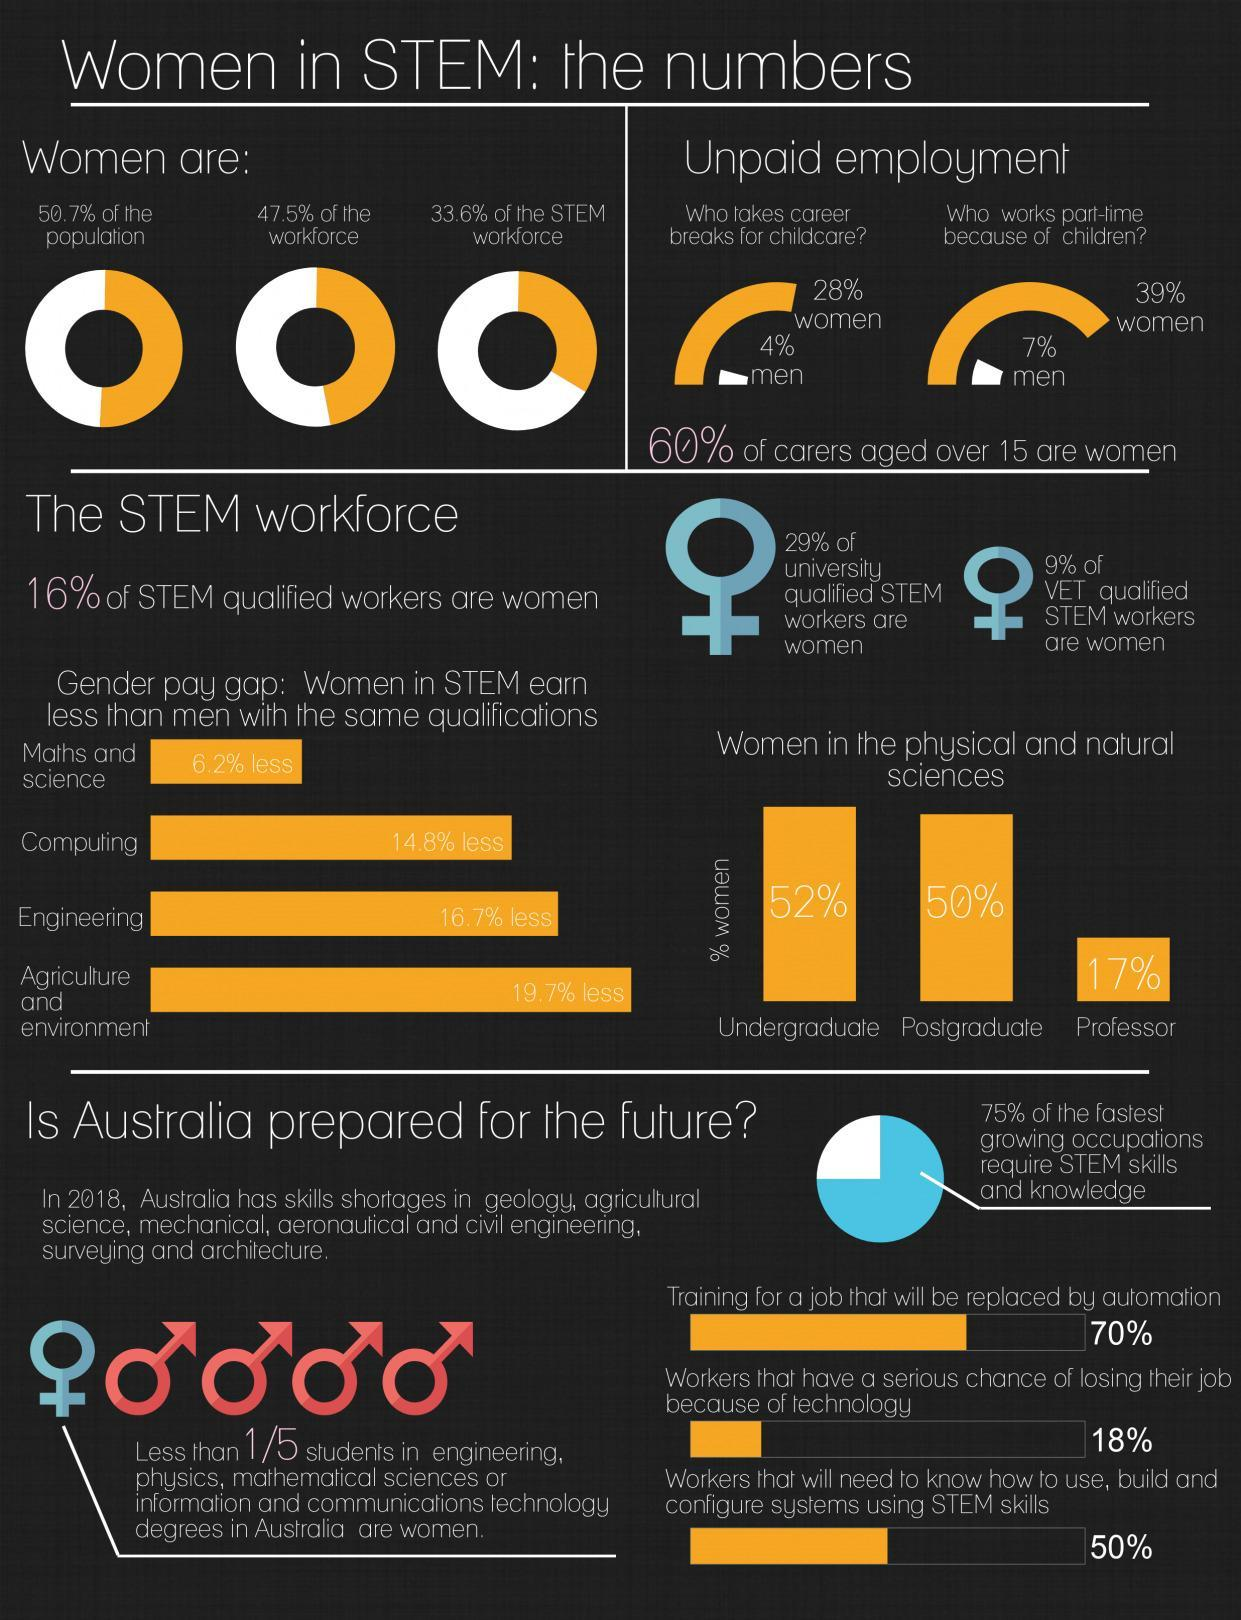What percentile of women are in the STEM field, 50.7%, 47.5%, or 33.6%?
Answer the question with a short phrase. 33.6% How many women out of 100 people are professors in physical and natural sciences? 17 What is the percentile difference in men and women taking breaks for child care? 24% 